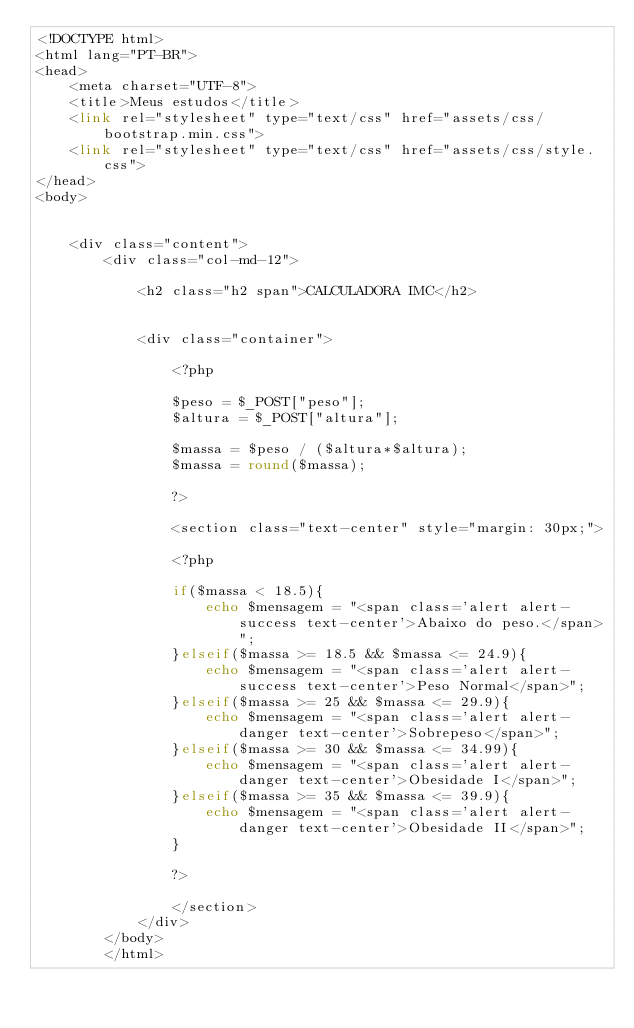Convert code to text. <code><loc_0><loc_0><loc_500><loc_500><_PHP_><!DOCTYPE html>
<html lang="PT-BR">
<head>
    <meta charset="UTF-8">
    <title>Meus estudos</title>
    <link rel="stylesheet" type="text/css" href="assets/css/bootstrap.min.css">
    <link rel="stylesheet" type="text/css" href="assets/css/style.css">
</head>
<body>


    <div class="content">
        <div class="col-md-12">

            <h2 class="h2 span">CALCULADORA IMC</h2>


            <div class="container">

                <?php

                $peso = $_POST["peso"];
                $altura = $_POST["altura"];

                $massa = $peso / ($altura*$altura);
                $massa = round($massa);

                ?>

                <section class="text-center" style="margin: 30px;">

                <?php    
 
                if($massa < 18.5){
                    echo $mensagem = "<span class='alert alert-success text-center'>Abaixo do peso.</span>";
                }elseif($massa >= 18.5 && $massa <= 24.9){
                    echo $mensagem = "<span class='alert alert-success text-center'>Peso Normal</span>";
                }elseif($massa >= 25 && $massa <= 29.9){
                    echo $mensagem = "<span class='alert alert-danger text-center'>Sobrepeso</span>";
                }elseif($massa >= 30 && $massa <= 34.99){
                    echo $mensagem = "<span class='alert alert-danger text-center'>Obesidade I</span>";
                }elseif($massa >= 35 && $massa <= 39.9){
                    echo $mensagem = "<span class='alert alert-danger text-center'>Obesidade II</span>";
                }

                ?>

                </section>
            </div>
        </body>
        </html></code> 